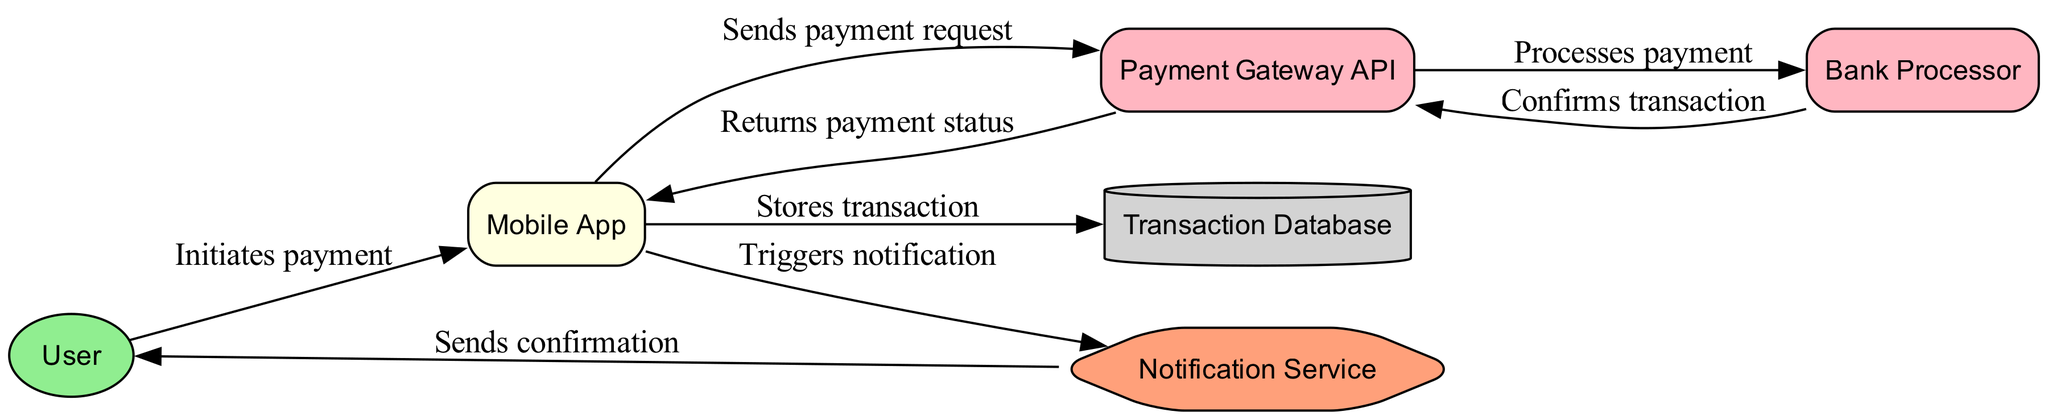What is the first action taken in this workflow? The workflow starts with the User initiating a payment, which is represented by the edge from 'User' to 'Mobile App' labeled 'Initiates payment.'
Answer: Initiates payment How many main components (nodes) are present in the diagram? The diagram includes six main components: User, Mobile App, Payment Gateway API, Bank Processor, Transaction Database, and Notification Service. Therefore, a count of those distinct elements results in a total of six nodes.
Answer: 6 Which entity confirms the transaction in this workflow? The edge from 'Bank Processor' to 'Payment Gateway API' indicates that the Bank Processor confirms the transaction, as noted in the label 'Confirms transaction.'
Answer: Bank Processor What is the last action that occurs in the workflow? The last action takes place as the Notification Service sends a confirmation to the User, shown by the edge from 'Notification Service' to 'User' labeled 'Sends confirmation.'
Answer: Sends confirmation What type of system is the Transaction Database characterized as in the diagram? The Transaction Database is represented as a database, indicated by its shape (cylinder) and the color (light gray) used in the diagram.
Answer: Database Which component communicates with the Mobile App about the payment status? The edge from 'Payment Gateway API' to 'Mobile App' specifies that the Payment Gateway API returns the payment status to the Mobile App, confirmed by the label 'Returns payment status.'
Answer: Payment Gateway API How many external systems are involved in the payment workflow? The diagram shows two external systems: Payment Gateway API and Bank Processor. Therefore, a count of these external distinct systems results in two external systems.
Answer: 2 What service does the Mobile App trigger after storing a transaction? After storing the transaction in the Transaction Database, the Mobile App triggers the Notification Service, as depicted in the edge labeled 'Triggers notification.'
Answer: Notification Service What action occurs after processing the payment? The action that follows payment processing is the Bank Processor confirming the transaction and returning to the Payment Gateway API, represented in the diagram as the label 'Confirms transaction.'
Answer: Confirms transaction 